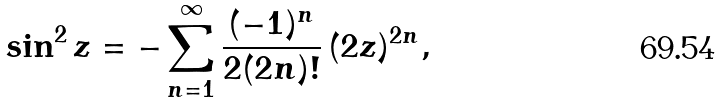Convert formula to latex. <formula><loc_0><loc_0><loc_500><loc_500>\sin ^ { 2 } z = - \sum _ { n = 1 } ^ { \infty } \frac { ( - 1 ) ^ { n } } { 2 ( 2 n ) ! } \, ( 2 z ) ^ { 2 n } ,</formula> 